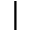Convert formula to latex. <formula><loc_0><loc_0><loc_500><loc_500>|</formula> 